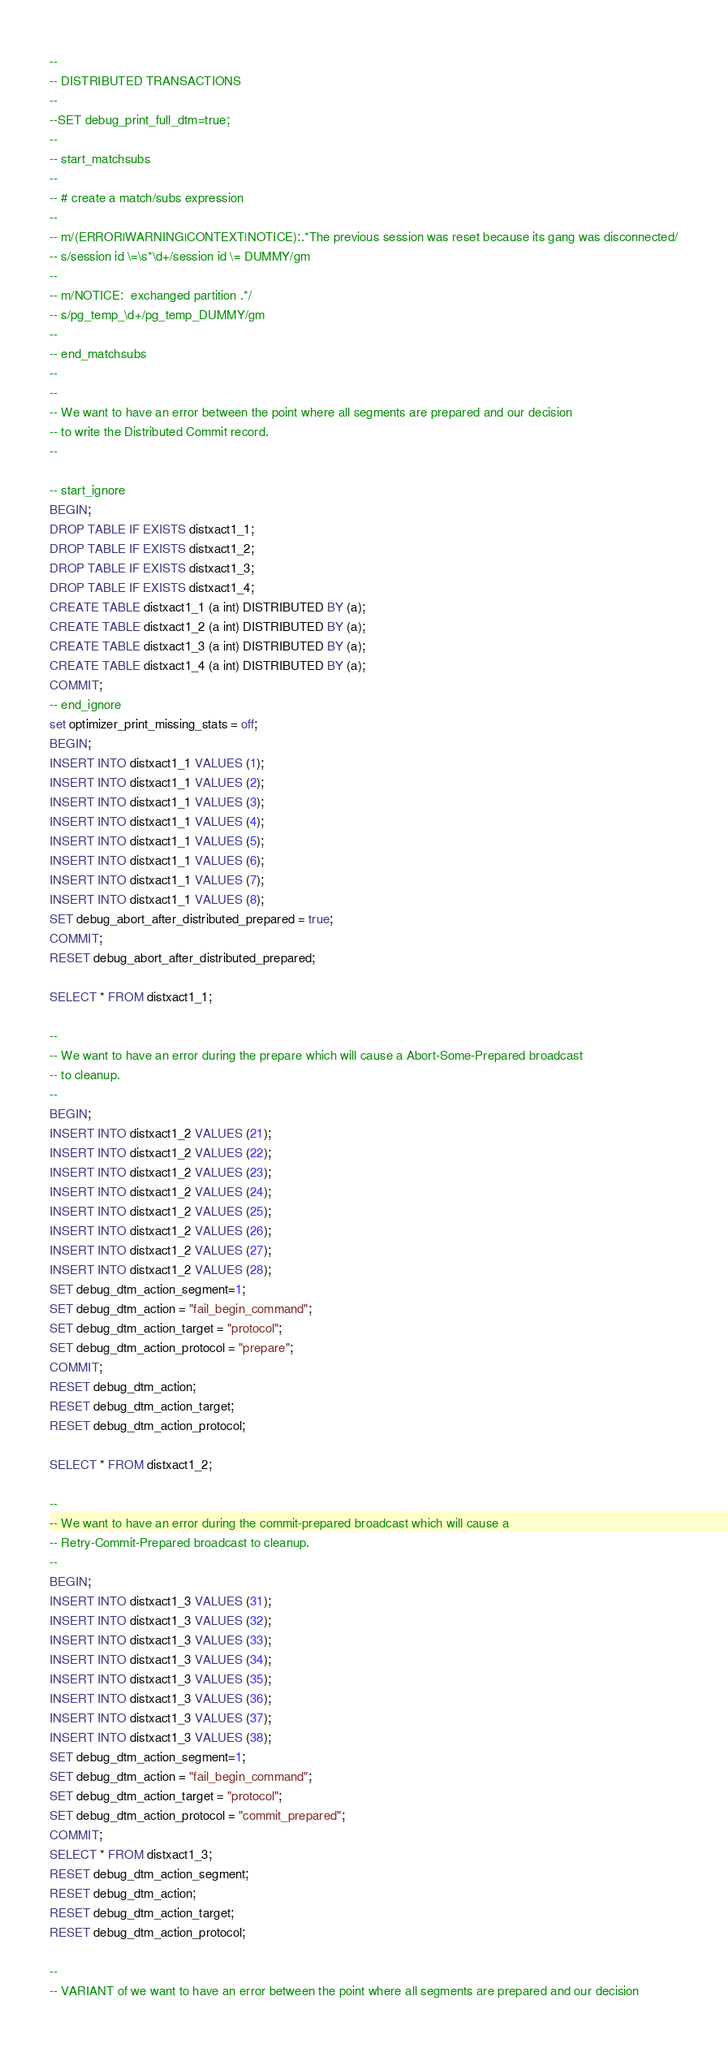Convert code to text. <code><loc_0><loc_0><loc_500><loc_500><_SQL_>--
-- DISTRIBUTED TRANSACTIONS
--
--SET debug_print_full_dtm=true;
--
-- start_matchsubs
--
-- # create a match/subs expression
--
-- m/(ERROR|WARNING|CONTEXT|NOTICE):.*The previous session was reset because its gang was disconnected/
-- s/session id \=\s*\d+/session id \= DUMMY/gm
--
-- m/NOTICE:  exchanged partition .*/
-- s/pg_temp_\d+/pg_temp_DUMMY/gm
--
-- end_matchsubs
--
--
-- We want to have an error between the point where all segments are prepared and our decision 
-- to write the Distributed Commit record.
--

-- start_ignore
BEGIN;
DROP TABLE IF EXISTS distxact1_1;
DROP TABLE IF EXISTS distxact1_2;
DROP TABLE IF EXISTS distxact1_3;
DROP TABLE IF EXISTS distxact1_4;
CREATE TABLE distxact1_1 (a int) DISTRIBUTED BY (a);
CREATE TABLE distxact1_2 (a int) DISTRIBUTED BY (a);
CREATE TABLE distxact1_3 (a int) DISTRIBUTED BY (a);
CREATE TABLE distxact1_4 (a int) DISTRIBUTED BY (a);
COMMIT;
-- end_ignore
set optimizer_print_missing_stats = off;
BEGIN;
INSERT INTO distxact1_1 VALUES (1);
INSERT INTO distxact1_1 VALUES (2);
INSERT INTO distxact1_1 VALUES (3);
INSERT INTO distxact1_1 VALUES (4);
INSERT INTO distxact1_1 VALUES (5);
INSERT INTO distxact1_1 VALUES (6);
INSERT INTO distxact1_1 VALUES (7);
INSERT INTO distxact1_1 VALUES (8);
SET debug_abort_after_distributed_prepared = true;
COMMIT;
RESET debug_abort_after_distributed_prepared;

SELECT * FROM distxact1_1;

--
-- We want to have an error during the prepare which will cause a Abort-Some-Prepared broadcast 
-- to cleanup.
--
BEGIN;
INSERT INTO distxact1_2 VALUES (21);
INSERT INTO distxact1_2 VALUES (22);
INSERT INTO distxact1_2 VALUES (23);
INSERT INTO distxact1_2 VALUES (24);
INSERT INTO distxact1_2 VALUES (25);
INSERT INTO distxact1_2 VALUES (26);
INSERT INTO distxact1_2 VALUES (27);
INSERT INTO distxact1_2 VALUES (28);
SET debug_dtm_action_segment=1;
SET debug_dtm_action = "fail_begin_command";
SET debug_dtm_action_target = "protocol";
SET debug_dtm_action_protocol = "prepare";
COMMIT;
RESET debug_dtm_action;
RESET debug_dtm_action_target;
RESET debug_dtm_action_protocol;

SELECT * FROM distxact1_2;

--
-- We want to have an error during the commit-prepared broadcast which will cause a
-- Retry-Commit-Prepared broadcast to cleanup.
--
BEGIN;
INSERT INTO distxact1_3 VALUES (31);
INSERT INTO distxact1_3 VALUES (32);
INSERT INTO distxact1_3 VALUES (33);
INSERT INTO distxact1_3 VALUES (34);
INSERT INTO distxact1_3 VALUES (35);
INSERT INTO distxact1_3 VALUES (36);
INSERT INTO distxact1_3 VALUES (37);
INSERT INTO distxact1_3 VALUES (38);
SET debug_dtm_action_segment=1;
SET debug_dtm_action = "fail_begin_command";
SET debug_dtm_action_target = "protocol";
SET debug_dtm_action_protocol = "commit_prepared";
COMMIT;
SELECT * FROM distxact1_3;
RESET debug_dtm_action_segment;
RESET debug_dtm_action;
RESET debug_dtm_action_target;
RESET debug_dtm_action_protocol;

--
-- VARIANT of we want to have an error between the point where all segments are prepared and our decision </code> 